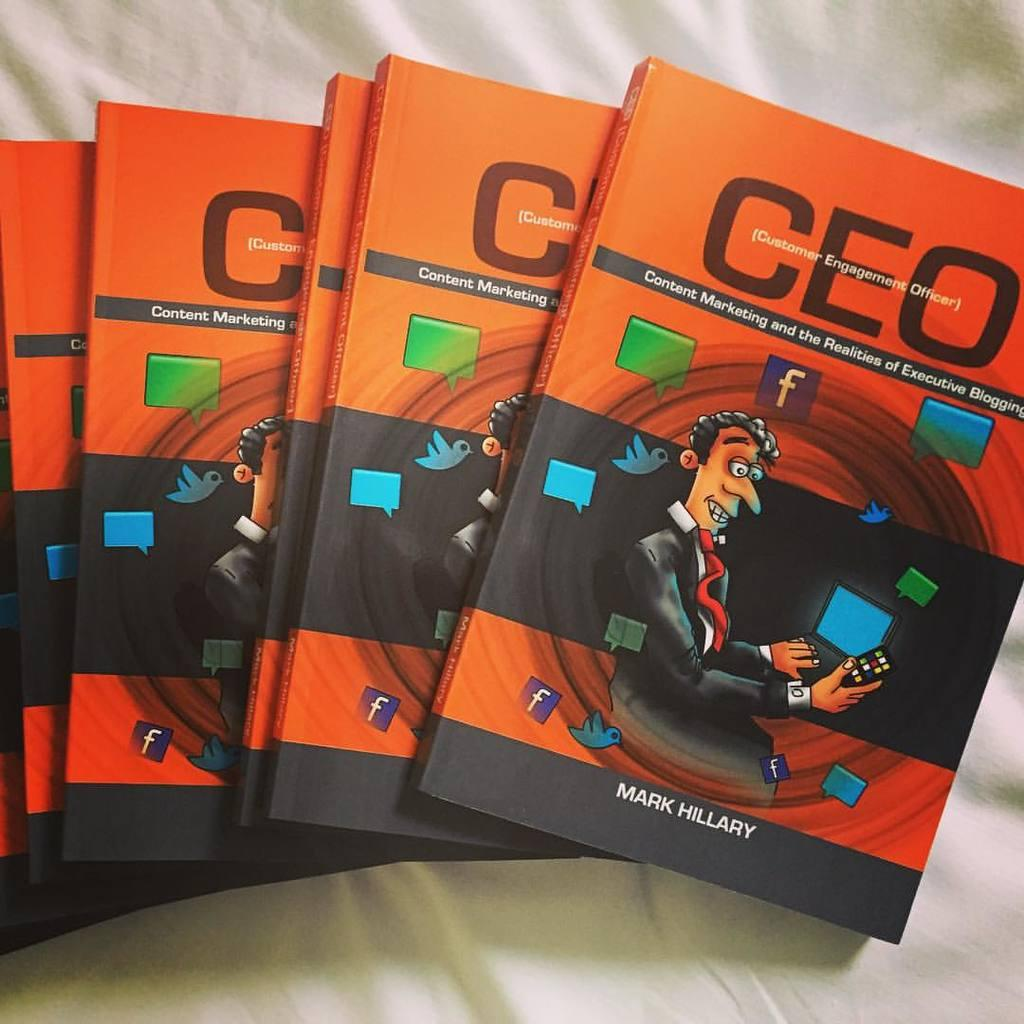<image>
Write a terse but informative summary of the picture. a collection of the same book that has the word ceo by mark hillary 